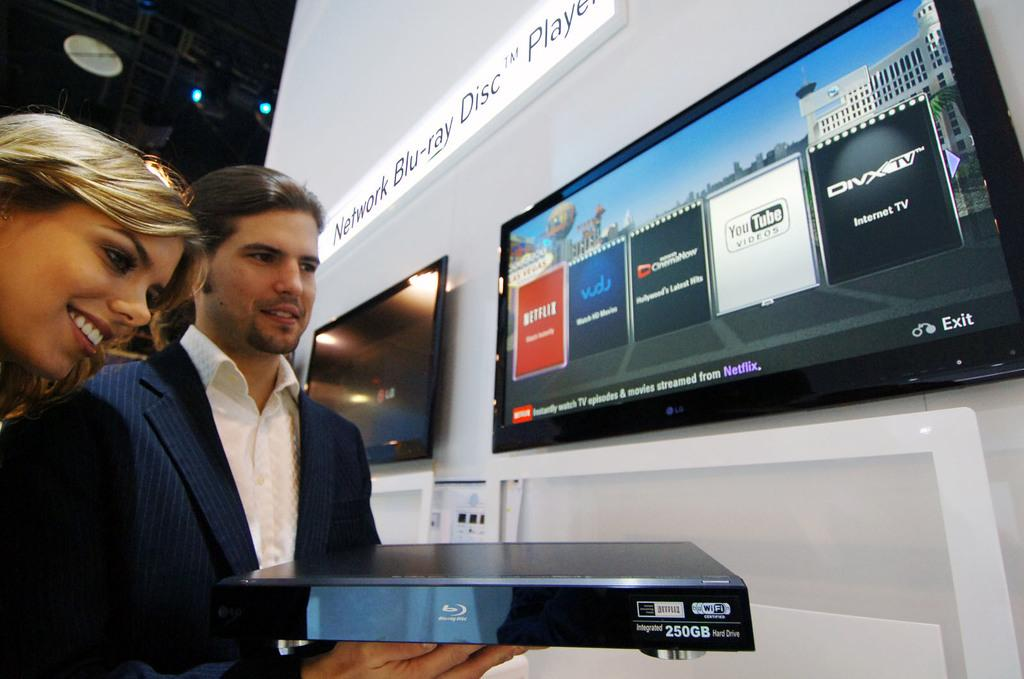How many people are present in the image? There are two people in the image. What is the facial expression of the people in the image? The people are smiling. What can be seen in the image besides the people? There is a device and objects visible in the image. What is written on the wall in the image? There is a name board on the wall. What type of electronic devices are on the wall? There are televisions on the wall. What type of meat is being cooked by the baby in the image? There is no baby or meat present in the image. 